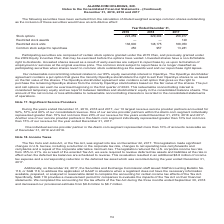According to Alarmcom Holdings's financial document, What were participating securities composed of? certain stock options granted under the 2015 Plan, and previously granted under the 2009 Equity Incentive Plan, that may be exercised before the options have vested.. The document states: "Participating securities are composed of certain stock options granted under the 2015 Plan, and previously granted under the 2009 Equity Incentive Pla..." Also, What was the company's equity ownership interest in OpenEye? According to the financial document, 85 (percentage). The relevant text states: "redeemable noncontrolling interest relates to our 85% equity ownership interest in OpenEye. The OpenEye stockholder agreement contains a put option that..." Also, How much were the Restricted stock units in 2019? According to the financial document, 136,600. The relevant text states: "icted stock awards — — 129 Restricted stock units 136,600 148,175 188,050 Common stock subject to repurchase 250 957 13,281..." Also, can you calculate: What was the change in Common stock subject to repurchase between 2018 and 2017? Based on the calculation: 957-13,281, the result is -12324. This is based on the information: "75 188,050 Common stock subject to repurchase 250 957 13,281 88,050 Common stock subject to repurchase 250 957 13,281..." The key data points involved are: 13,281, 957. Also, How many years did restricted stock units exceed 150,000? Based on the analysis, there are 1 instances. The counting process: 2017. Also, can you calculate: What was the percentage change in Common stock subject to repurchase between 2018 and 2019? To answer this question, I need to perform calculations using the financial data. The calculation is: (250-957)/957, which equals -73.88 (percentage). This is based on the information: "75 188,050 Common stock subject to repurchase 250 957 13,281 48,175 188,050 Common stock subject to repurchase 250 957 13,281..." The key data points involved are: 250, 957. 